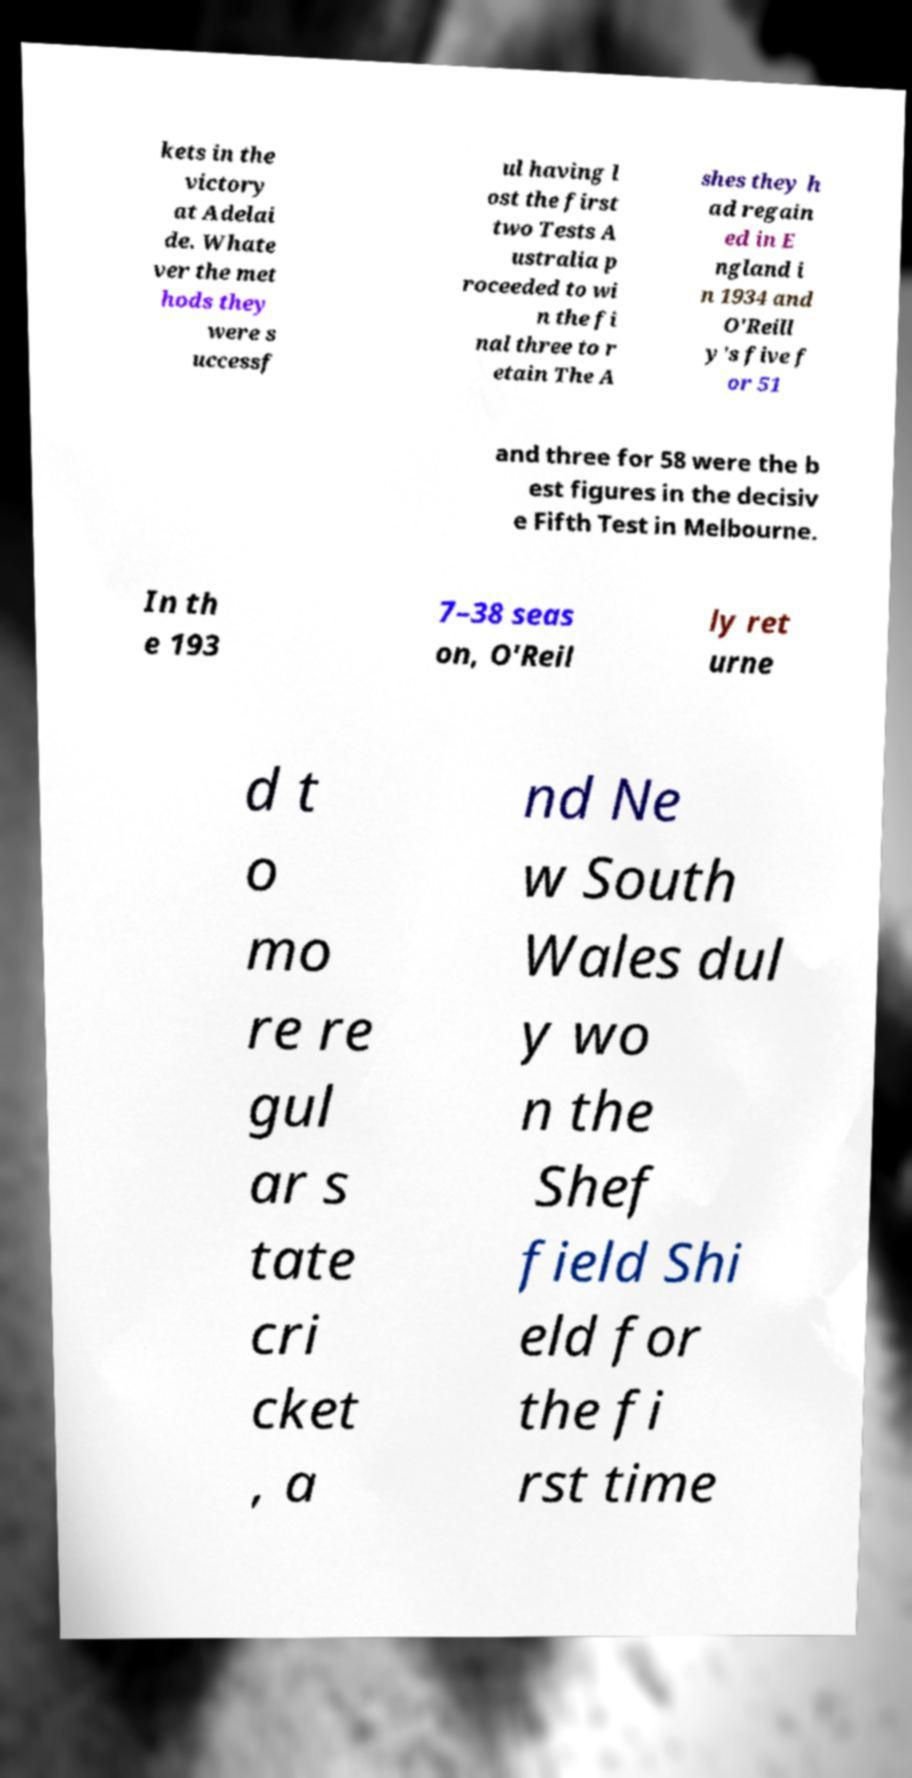Please read and relay the text visible in this image. What does it say? kets in the victory at Adelai de. Whate ver the met hods they were s uccessf ul having l ost the first two Tests A ustralia p roceeded to wi n the fi nal three to r etain The A shes they h ad regain ed in E ngland i n 1934 and O'Reill y's five f or 51 and three for 58 were the b est figures in the decisiv e Fifth Test in Melbourne. In th e 193 7–38 seas on, O'Reil ly ret urne d t o mo re re gul ar s tate cri cket , a nd Ne w South Wales dul y wo n the Shef field Shi eld for the fi rst time 